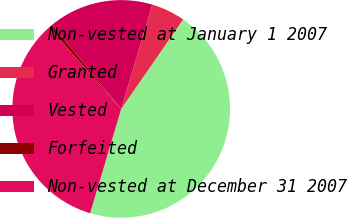Convert chart. <chart><loc_0><loc_0><loc_500><loc_500><pie_chart><fcel>Non-vested at January 1 2007<fcel>Granted<fcel>Vested<fcel>Forfeited<fcel>Non-vested at December 31 2007<nl><fcel>44.97%<fcel>5.03%<fcel>15.57%<fcel>0.56%<fcel>33.87%<nl></chart> 